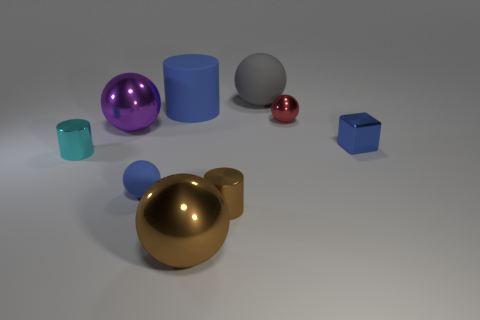How many things are either tiny balls to the left of the large gray object or blue metal spheres?
Your answer should be compact. 1. There is a large metallic sphere in front of the shiny cylinder that is on the left side of the small blue thing on the left side of the tiny red thing; what is its color?
Offer a terse response. Brown. There is a cube that is the same material as the red object; what color is it?
Offer a terse response. Blue. How many small brown things are the same material as the gray thing?
Keep it short and to the point. 0. There is a metallic thing that is right of the red sphere; is its size the same as the big gray rubber sphere?
Your response must be concise. No. There is a rubber sphere that is the same size as the rubber cylinder; what color is it?
Make the answer very short. Gray. What number of brown metal cylinders are behind the tiny brown object?
Provide a succinct answer. 0. Are there any gray rubber spheres?
Your answer should be very brief. Yes. How big is the metallic cylinder that is to the right of the small ball in front of the tiny metal cylinder behind the tiny brown thing?
Provide a short and direct response. Small. How many other things are there of the same size as the cyan cylinder?
Your answer should be very brief. 4. 